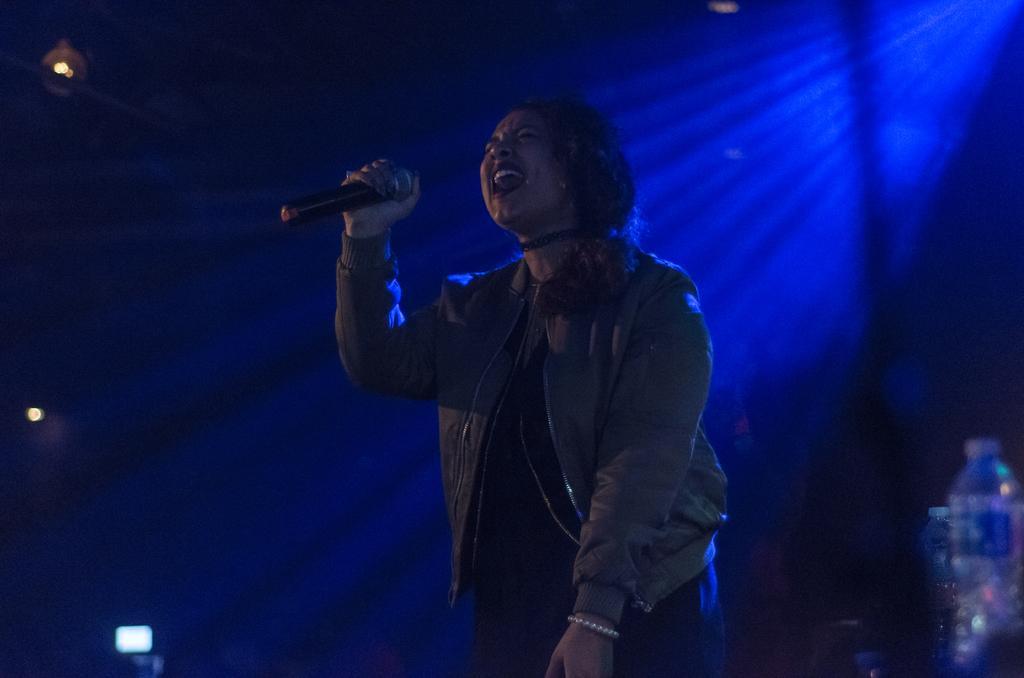In one or two sentences, can you explain what this image depicts? A woman is holding microphone, this is bottle. 